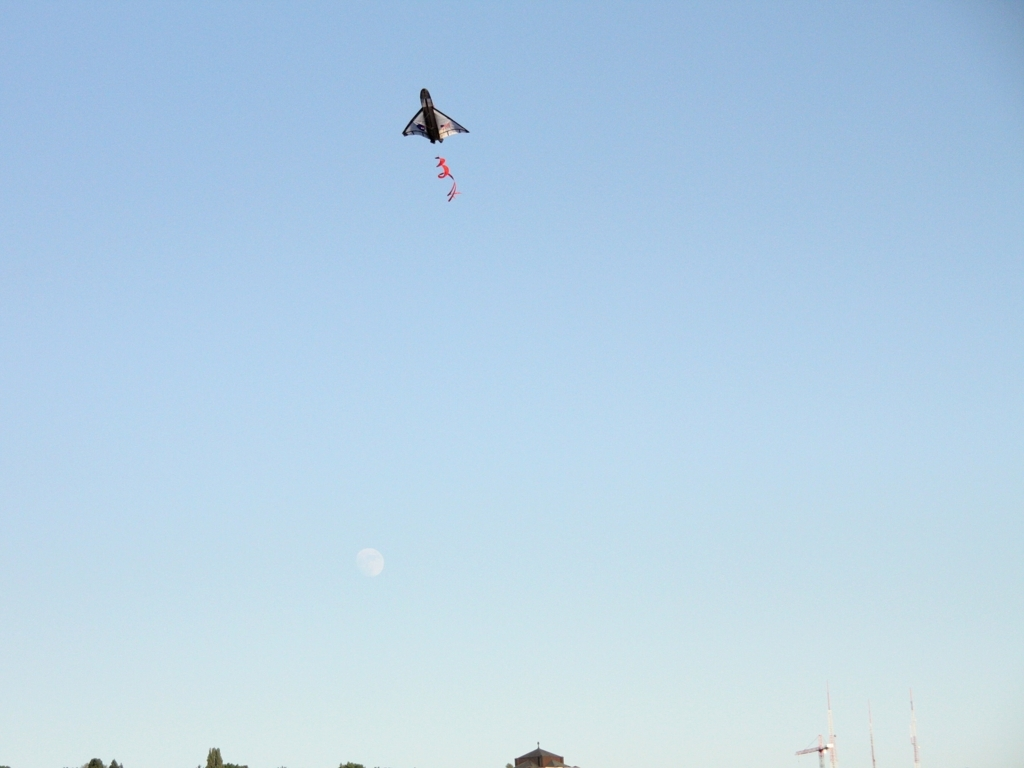Are there any sharpness issues in the image?
A. No
B. Yes
Answer with the option's letter from the given choices directly.
 A. 